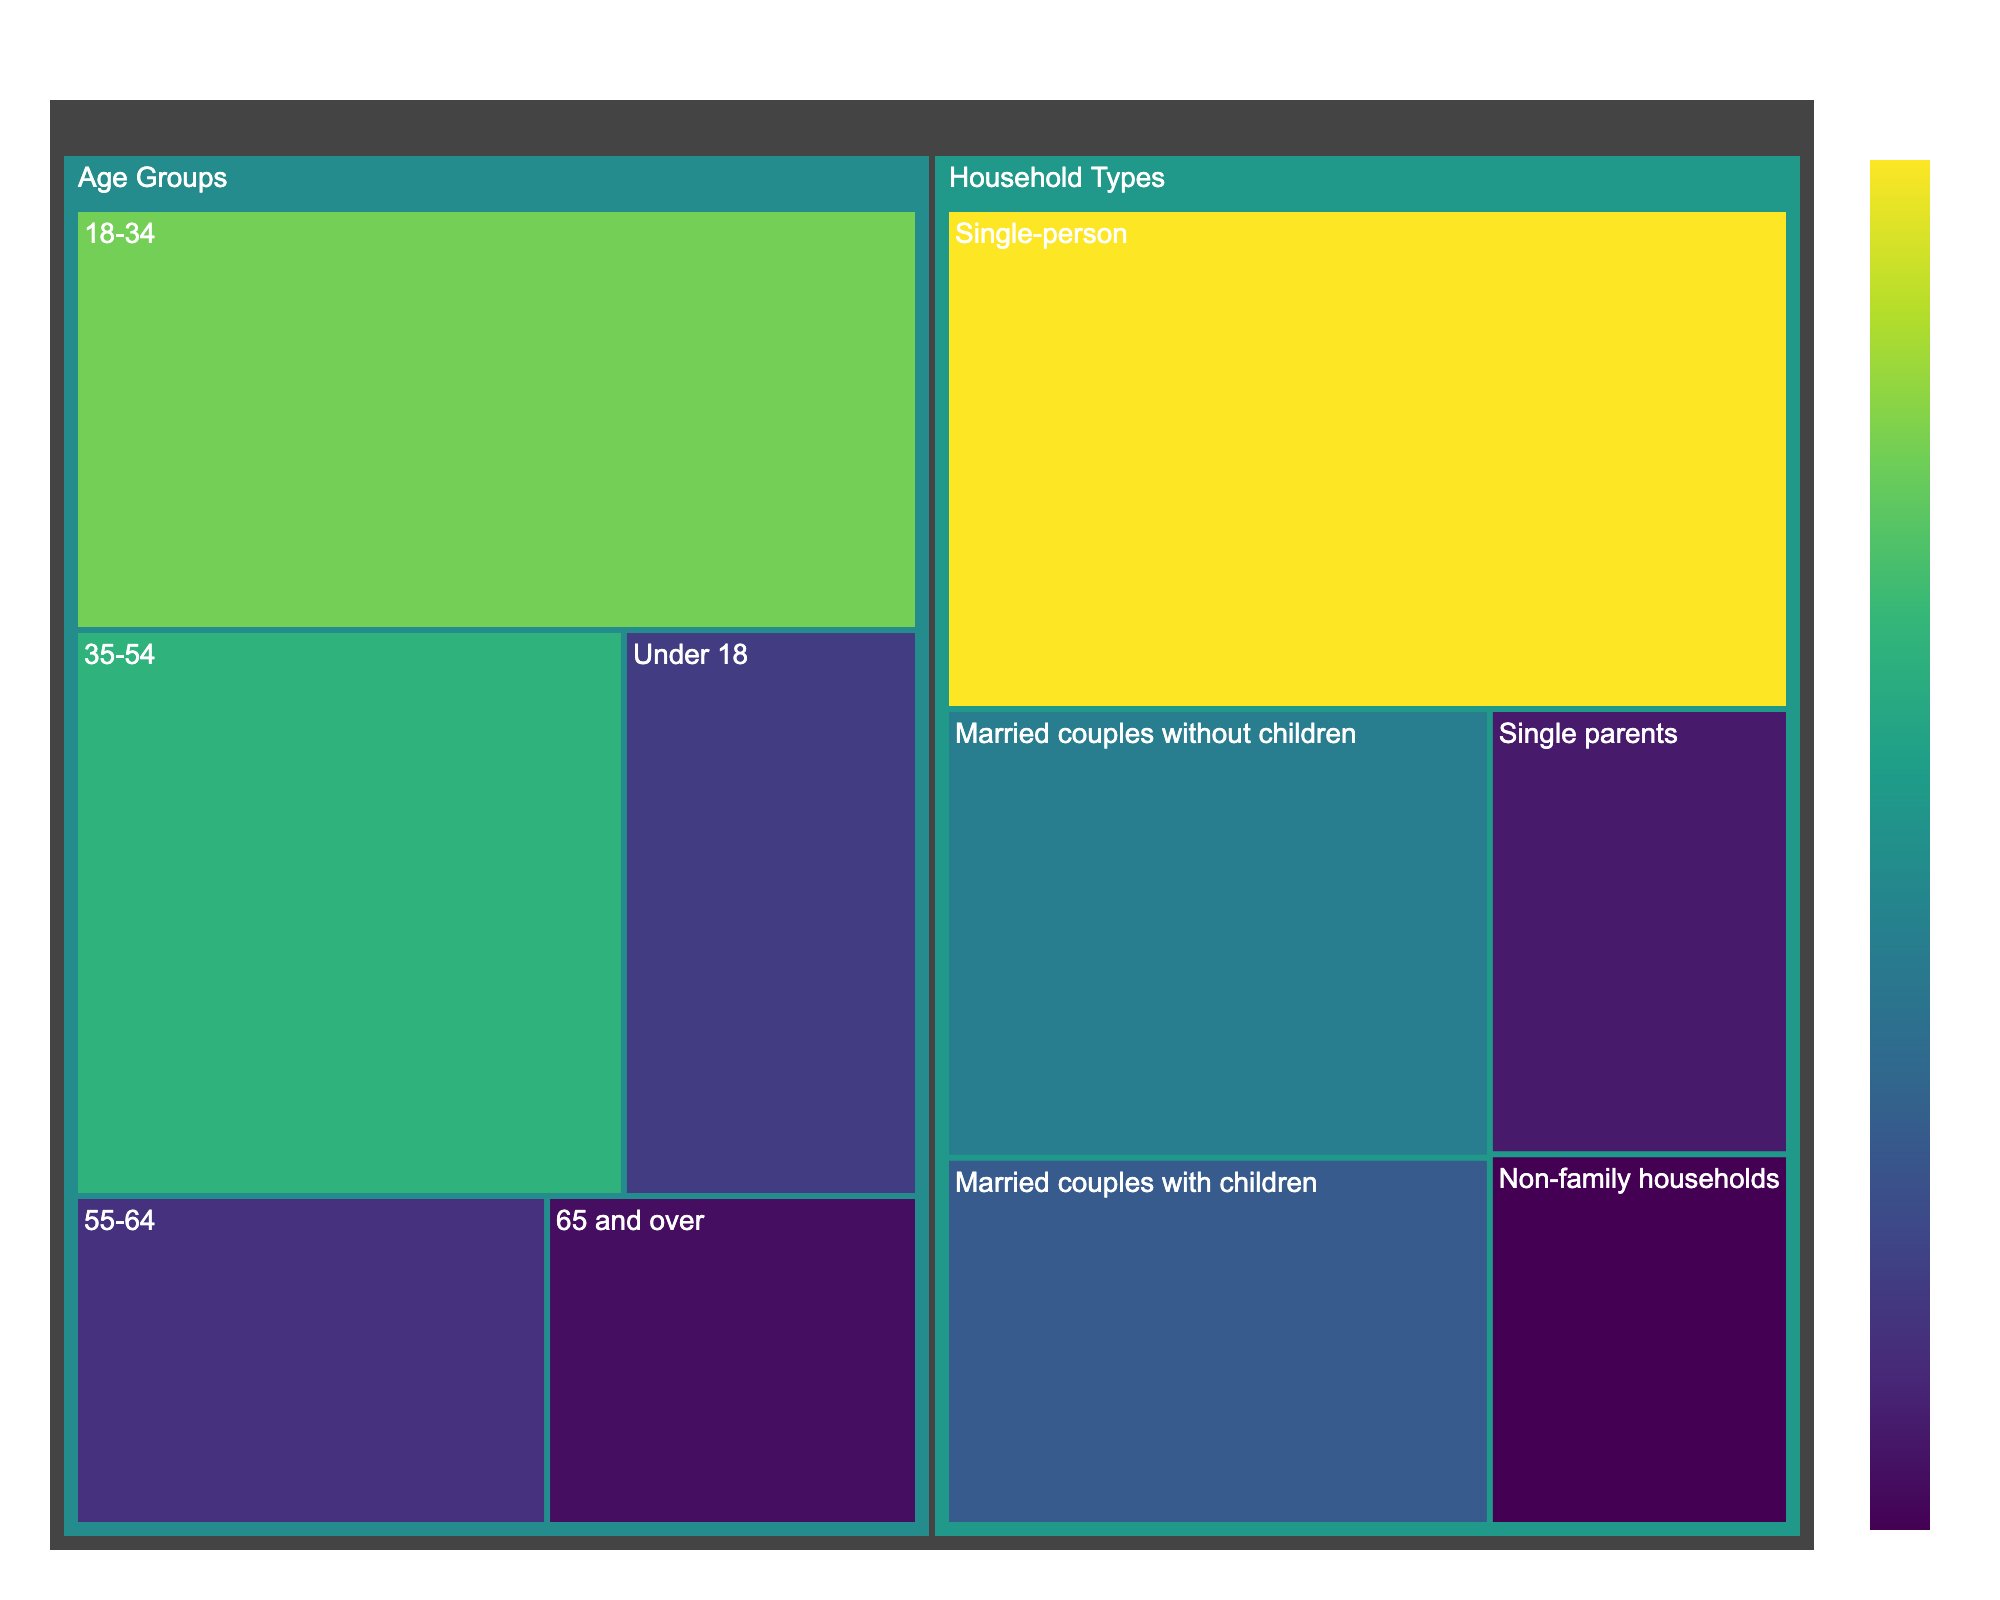What is the title of the treemap? The title is located at the top of the figure and it describes what the entire treemap represents.
Answer: Silverlake Population Breakdown Which age group has the highest population percentage? The treemap has blocks representing each age group's percentage. Look for the largest block under "Age Groups".
Answer: 18-34 How many household types are represented in the treemap? Count the number of distinct subcategories under the "Household Types" category.
Answer: 5 What is the combined percentage of the age groups 35-54 and 55-64? Refer to the blocks for these age groups and add their values: 28% + 14% = 42%
Answer: 42% Which household type has the least population? Identify the smallest block under "Household Types".
Answer: Non-family households Is the percentage of married couples with children greater than single parents? Compare the values of the blocks for "Married couples with children" and "Single parents": 18% vs. 12%.
Answer: Yes How does the population percentage of children (Under 18) compare to seniors (65 and over)? Compare the values of these two age groups: 15% for children and 11% for seniors.
Answer: Children have a higher percentage What is the total percentage of all household types combined? The sum of all household types' percentages should equal 100%.
Answer: 100% Which category (Age Groups or Household Types) has the highest individual percentage? Look for the highest value among all blocks. Compare the highest in Age Groups (32%) and Household Types (38%).
Answer: Household Types What is the smallest combined percentage in the Age Groups category? Find the two smallest values in Age Groups and add them: 14% + 11% = 25%
Answer: 25% 